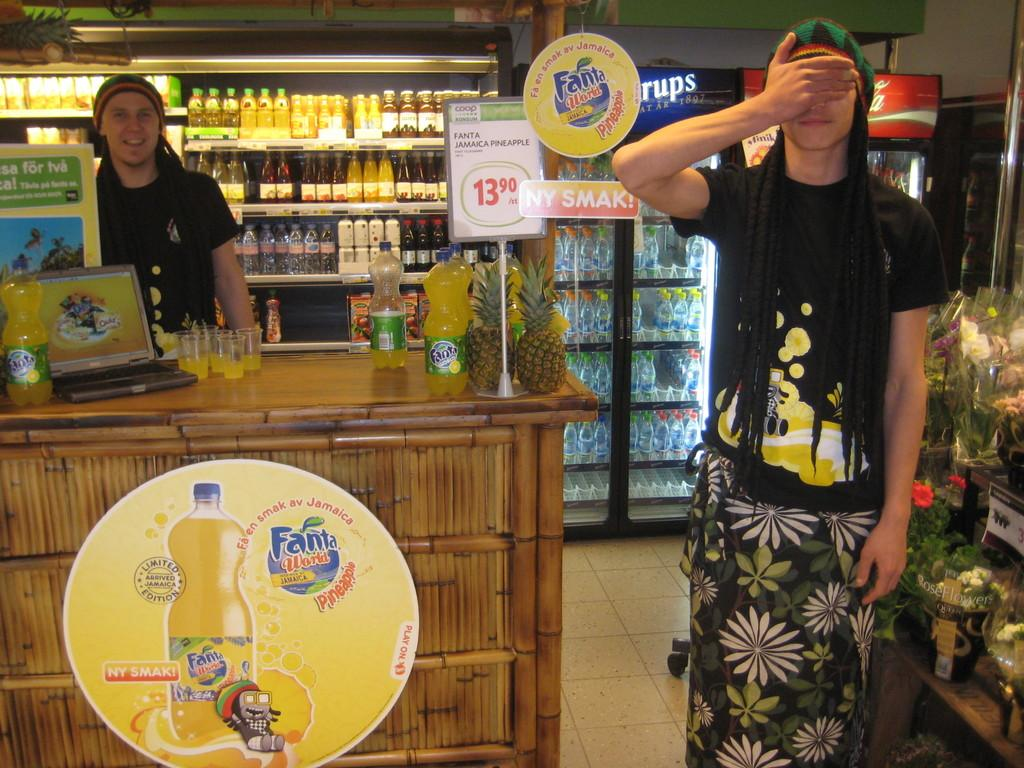<image>
Relay a brief, clear account of the picture shown. A man with dreads standing covering his eyes inside a store as he's beside a stand that says Fanta World Pineapple 